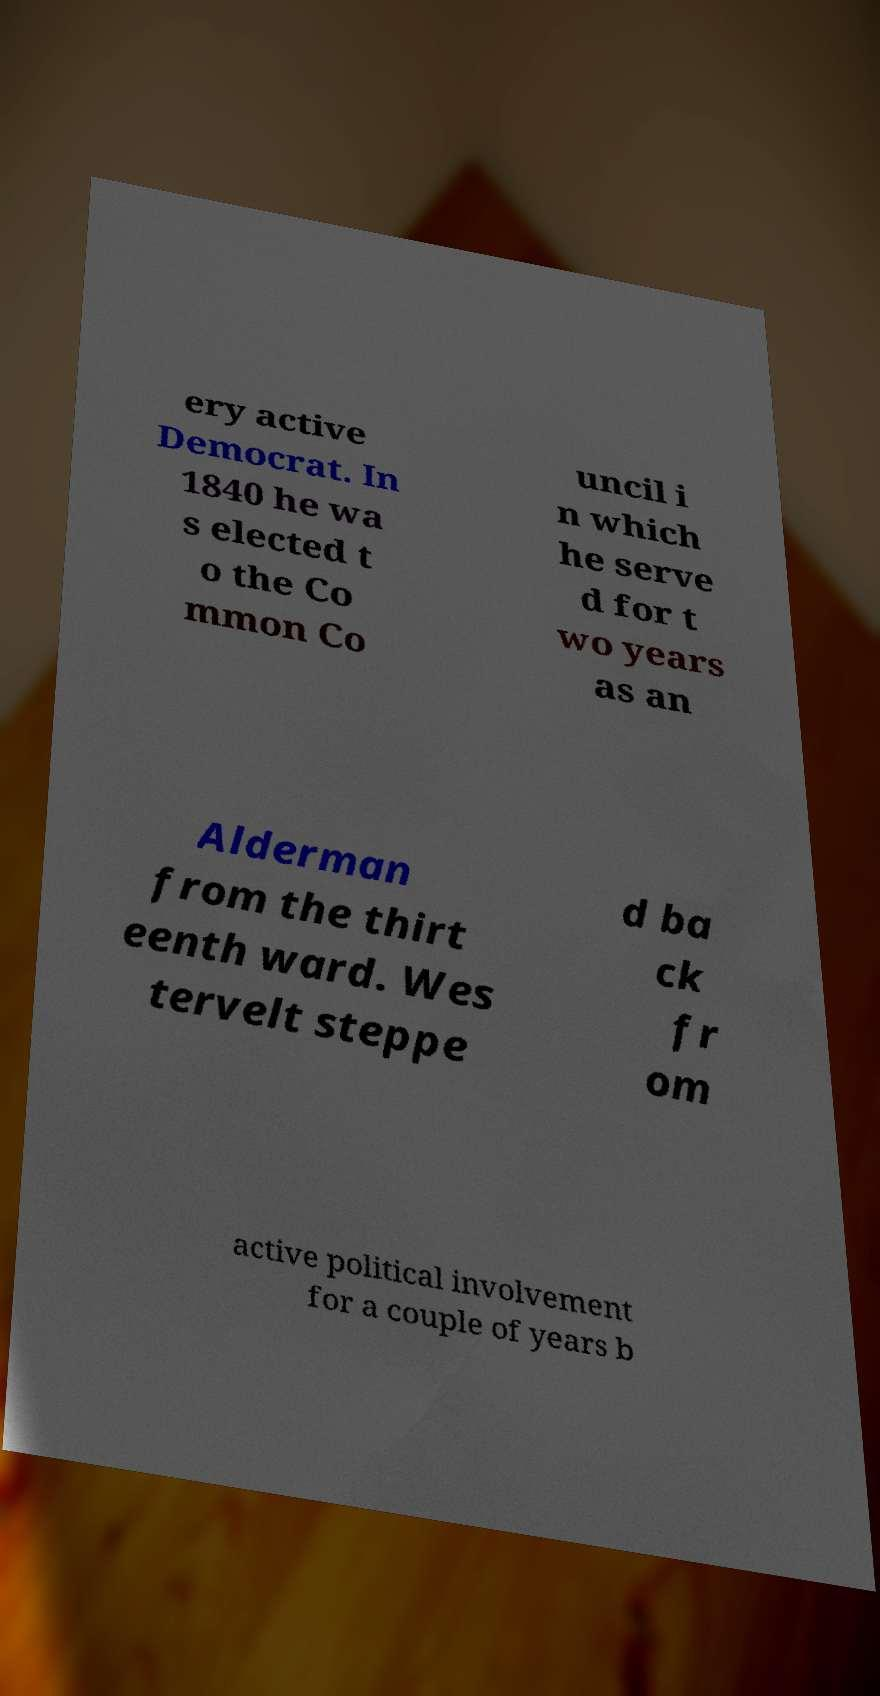There's text embedded in this image that I need extracted. Can you transcribe it verbatim? ery active Democrat. In 1840 he wa s elected t o the Co mmon Co uncil i n which he serve d for t wo years as an Alderman from the thirt eenth ward. Wes tervelt steppe d ba ck fr om active political involvement for a couple of years b 